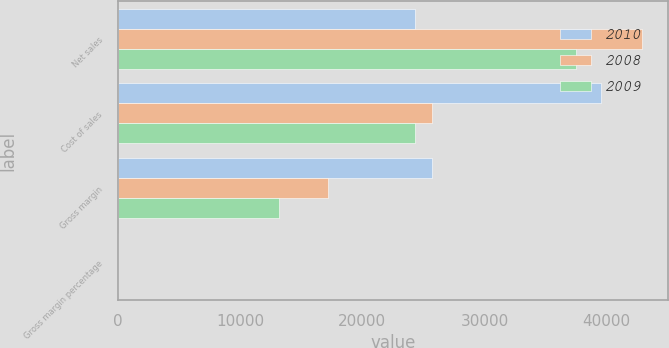Convert chart. <chart><loc_0><loc_0><loc_500><loc_500><stacked_bar_chart><ecel><fcel>Net sales<fcel>Cost of sales<fcel>Gross margin<fcel>Gross margin percentage<nl><fcel>2010<fcel>24294<fcel>39541<fcel>25684<fcel>39.4<nl><fcel>2008<fcel>42905<fcel>25683<fcel>17222<fcel>40.1<nl><fcel>2009<fcel>37491<fcel>24294<fcel>13197<fcel>35.2<nl></chart> 